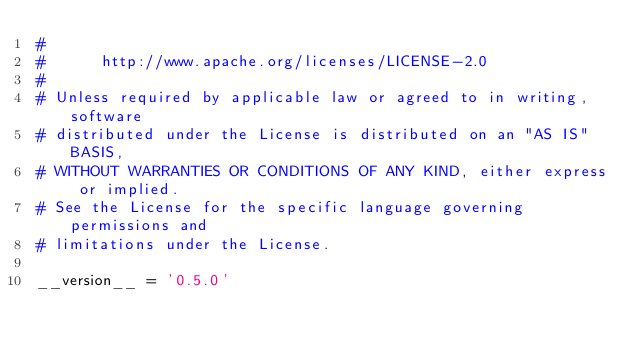Convert code to text. <code><loc_0><loc_0><loc_500><loc_500><_Python_>#
#      http://www.apache.org/licenses/LICENSE-2.0
#
# Unless required by applicable law or agreed to in writing, software
# distributed under the License is distributed on an "AS IS" BASIS,
# WITHOUT WARRANTIES OR CONDITIONS OF ANY KIND, either express or implied.
# See the License for the specific language governing permissions and
# limitations under the License.

__version__ = '0.5.0'
</code> 